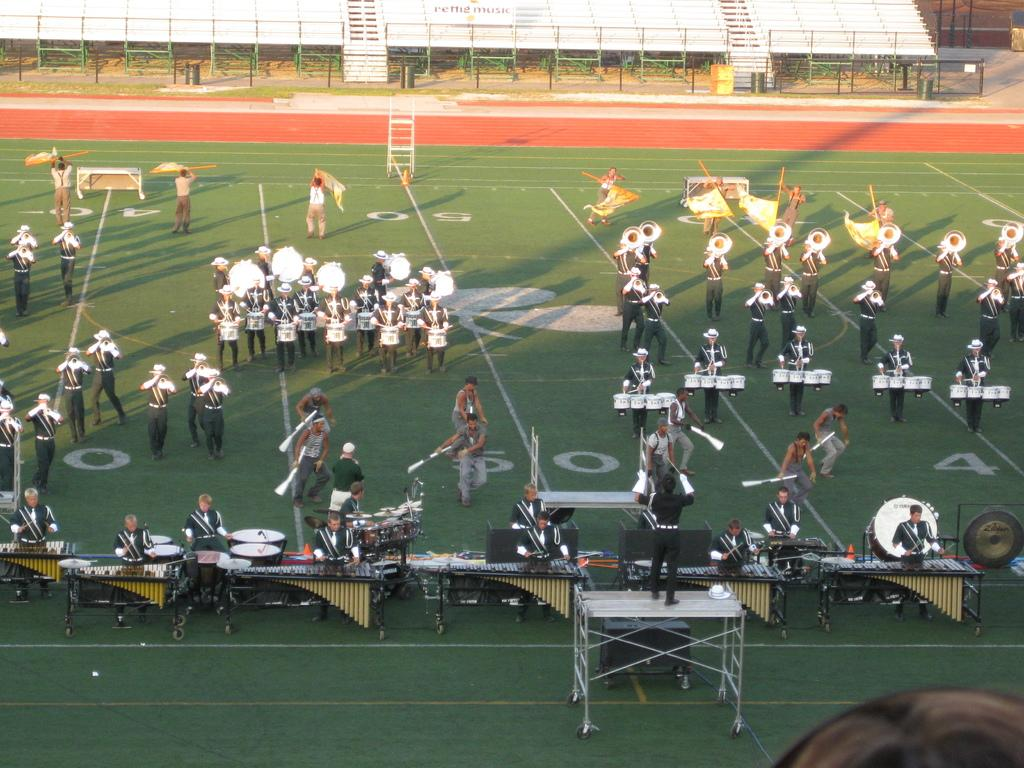What is happening in the image? There is a group of people in the image, and they are performing different musical actions. Where are the people performing these actions? The actions are taking place on the ground. What type of garden can be seen in the image? There is no garden present in the image; it features a group of people performing musical actions on the ground. What fact can be learned about the sock in the image? There is no sock present in the image, so no fact can be learned about it. 